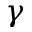Convert formula to latex. <formula><loc_0><loc_0><loc_500><loc_500>\gamma</formula> 